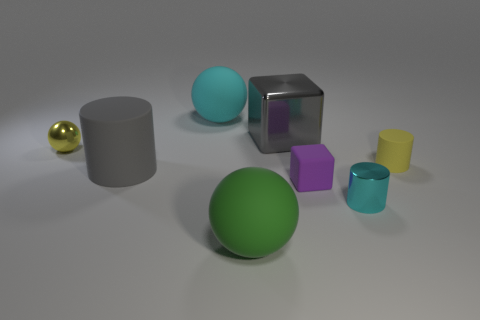Add 1 purple objects. How many objects exist? 9 Subtract all cyan cylinders. How many cylinders are left? 2 Subtract all large cyan spheres. How many spheres are left? 2 Add 8 green spheres. How many green spheres are left? 9 Add 4 gray shiny cubes. How many gray shiny cubes exist? 5 Subtract 1 purple cubes. How many objects are left? 7 Subtract all blocks. How many objects are left? 6 Subtract 1 blocks. How many blocks are left? 1 Subtract all cyan blocks. Subtract all blue balls. How many blocks are left? 2 Subtract all red spheres. How many yellow cylinders are left? 1 